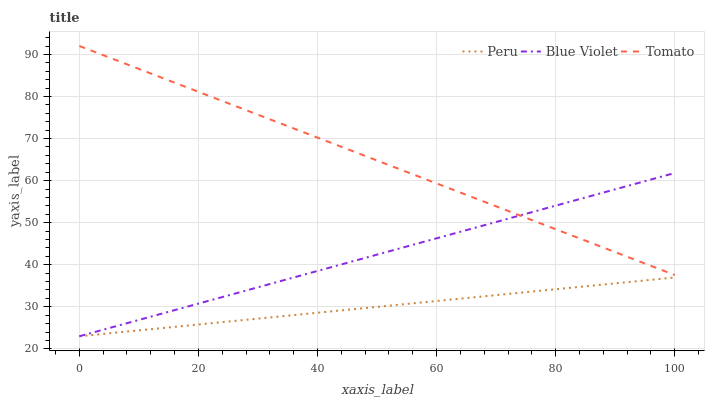Does Peru have the minimum area under the curve?
Answer yes or no. Yes. Does Tomato have the maximum area under the curve?
Answer yes or no. Yes. Does Blue Violet have the minimum area under the curve?
Answer yes or no. No. Does Blue Violet have the maximum area under the curve?
Answer yes or no. No. Is Blue Violet the smoothest?
Answer yes or no. Yes. Is Tomato the roughest?
Answer yes or no. Yes. Is Peru the smoothest?
Answer yes or no. No. Is Peru the roughest?
Answer yes or no. No. Does Blue Violet have the highest value?
Answer yes or no. No. Is Peru less than Tomato?
Answer yes or no. Yes. Is Tomato greater than Peru?
Answer yes or no. Yes. Does Peru intersect Tomato?
Answer yes or no. No. 